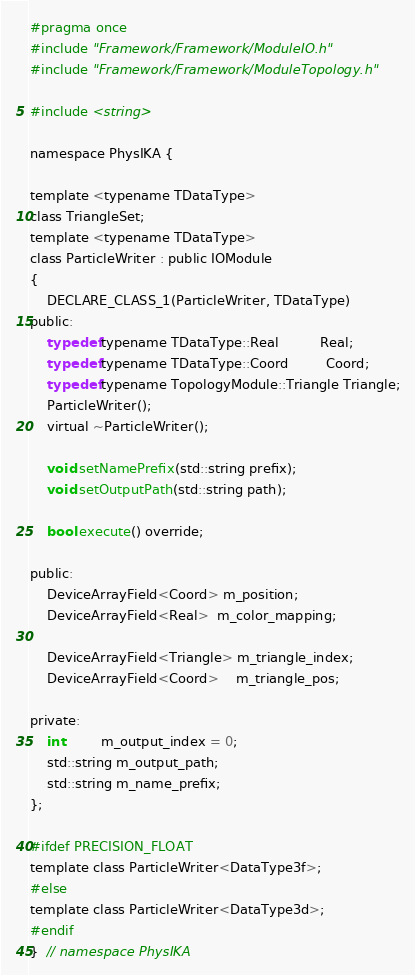<code> <loc_0><loc_0><loc_500><loc_500><_C_>#pragma once
#include "Framework/Framework/ModuleIO.h"
#include "Framework/Framework/ModuleTopology.h"

#include <string>

namespace PhysIKA {

template <typename TDataType>
class TriangleSet;
template <typename TDataType>
class ParticleWriter : public IOModule
{
    DECLARE_CLASS_1(ParticleWriter, TDataType)
public:
    typedef typename TDataType::Real          Real;
    typedef typename TDataType::Coord         Coord;
    typedef typename TopologyModule::Triangle Triangle;
    ParticleWriter();
    virtual ~ParticleWriter();

    void setNamePrefix(std::string prefix);
    void setOutputPath(std::string path);

    bool execute() override;

public:
    DeviceArrayField<Coord> m_position;
    DeviceArrayField<Real>  m_color_mapping;

    DeviceArrayField<Triangle> m_triangle_index;
    DeviceArrayField<Coord>    m_triangle_pos;

private:
    int         m_output_index = 0;
    std::string m_output_path;
    std::string m_name_prefix;
};

#ifdef PRECISION_FLOAT
template class ParticleWriter<DataType3f>;
#else
template class ParticleWriter<DataType3d>;
#endif
}  // namespace PhysIKA
</code> 